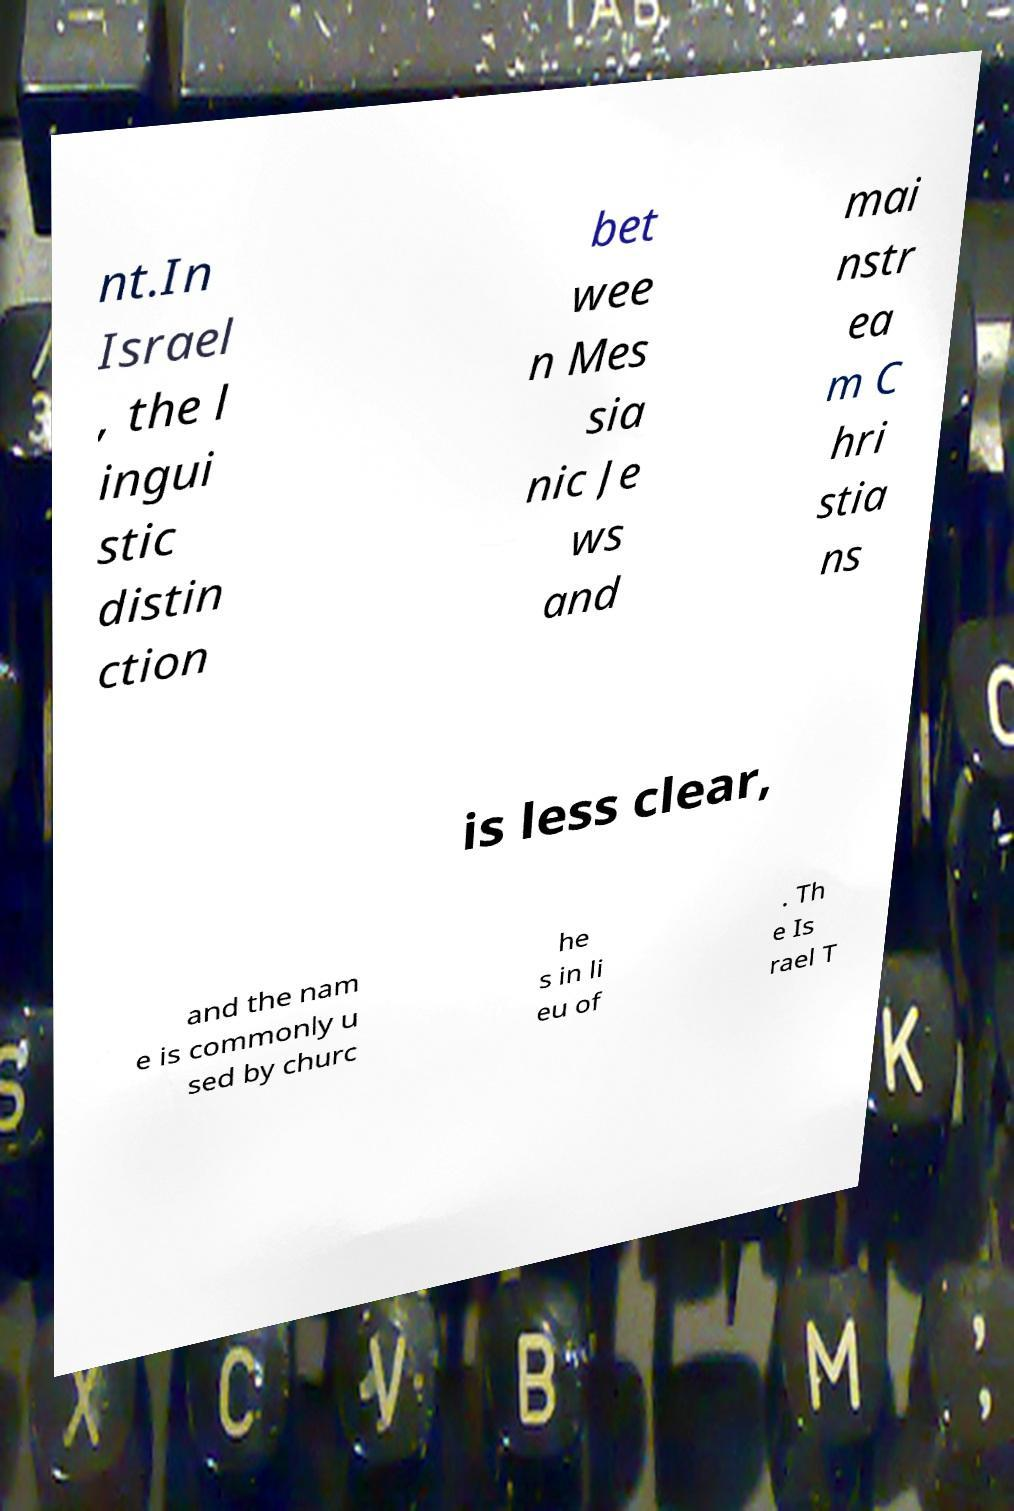Please identify and transcribe the text found in this image. nt.In Israel , the l ingui stic distin ction bet wee n Mes sia nic Je ws and mai nstr ea m C hri stia ns is less clear, and the nam e is commonly u sed by churc he s in li eu of . Th e Is rael T 